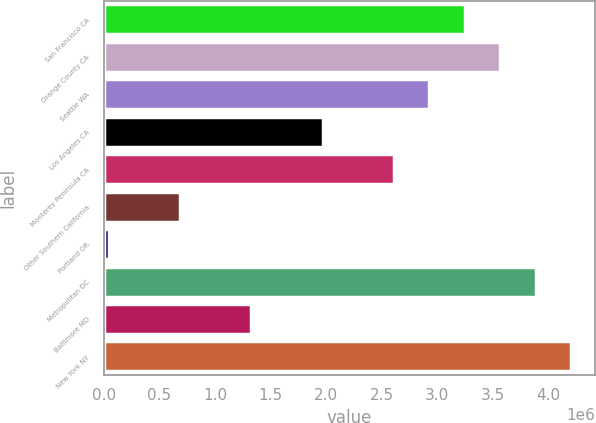<chart> <loc_0><loc_0><loc_500><loc_500><bar_chart><fcel>San Francisco CA<fcel>Orange County CA<fcel>Seattle WA<fcel>Los Angeles CA<fcel>Monterey Peninsula CA<fcel>Other Southern California<fcel>Portland OR<fcel>Metropolitan DC<fcel>Baltimore MD<fcel>New York NY<nl><fcel>3.24975e+06<fcel>3.56989e+06<fcel>2.9296e+06<fcel>1.96918e+06<fcel>2.60946e+06<fcel>688603<fcel>48317<fcel>3.89003e+06<fcel>1.32889e+06<fcel>4.21018e+06<nl></chart> 